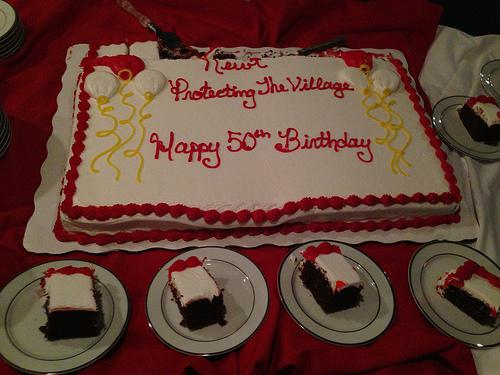Question: how many slices of cake are there?
Choices:
A. 5.
B. 1.
C. 6.
D. 8.
Answer with the letter. Answer: A Question: why is there a cake?
Choices:
A. Birthday party.
B. Christmas.
C. Easter.
D. Thanksgiving.
Answer with the letter. Answer: A Question: when is the cake made?
Choices:
A. For Christmas.
B. For Easter.
C. For Thanksgiving.
D. For a birthday.
Answer with the letter. Answer: D Question: how old is the celebration for?
Choices:
A. 50.
B. 40.
C. 20.
D. 10.
Answer with the letter. Answer: A 